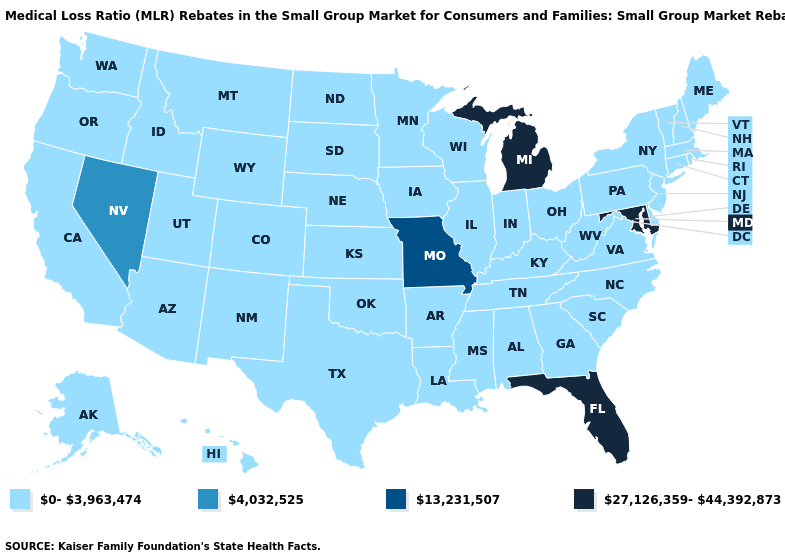Does the map have missing data?
Quick response, please. No. Among the states that border Nevada , which have the lowest value?
Quick response, please. Arizona, California, Idaho, Oregon, Utah. What is the value of Indiana?
Write a very short answer. 0-3,963,474. Name the states that have a value in the range 13,231,507?
Short answer required. Missouri. Does Iowa have the same value as Florida?
Concise answer only. No. Which states have the highest value in the USA?
Write a very short answer. Florida, Maryland, Michigan. What is the highest value in states that border Kansas?
Be succinct. 13,231,507. Does Georgia have the highest value in the South?
Write a very short answer. No. What is the highest value in the West ?
Answer briefly. 4,032,525. What is the value of Oklahoma?
Answer briefly. 0-3,963,474. Does Arizona have the lowest value in the West?
Answer briefly. Yes. Does Hawaii have a lower value than Tennessee?
Write a very short answer. No. 